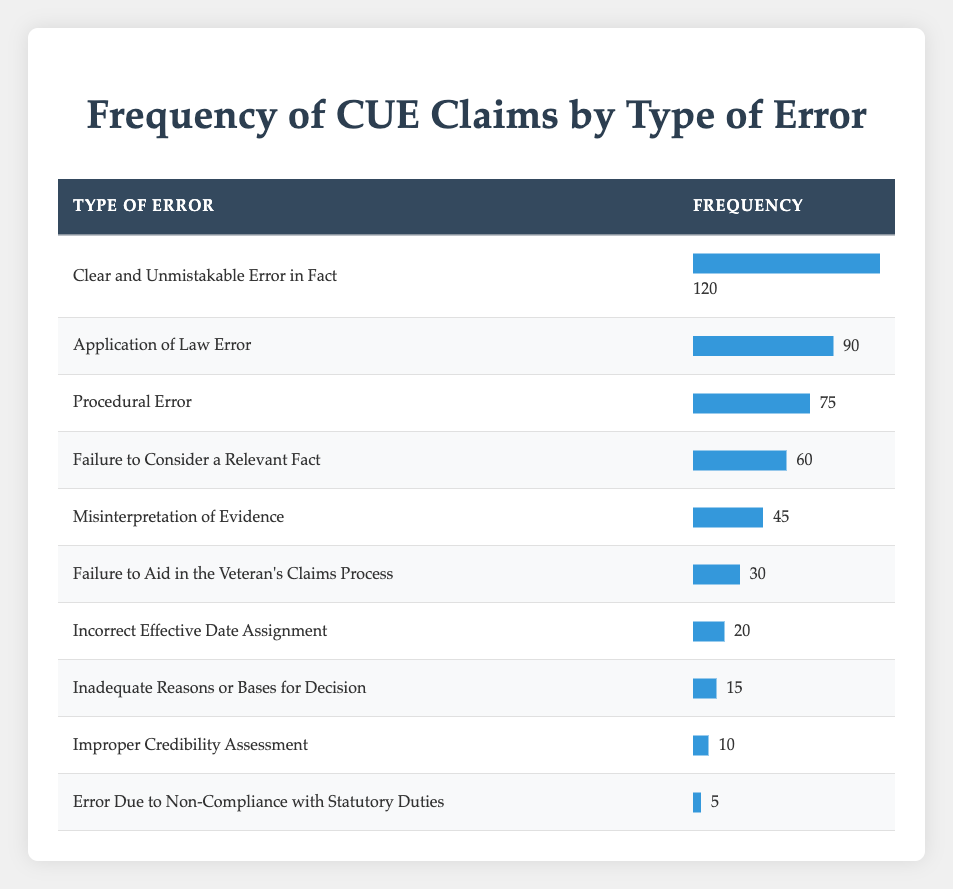What is the frequency of the most common type of error? The table shows that the most common type of error is "Clear and Unmistakable Error in Fact," which has a frequency of 120.
Answer: 120 What is the frequency of "Misinterpretation of Evidence"? By looking at the table, we can see that "Misinterpretation of Evidence" has a frequency of 45.
Answer: 45 Is the frequency of "Procedural Error" greater than that of "Failure to Aid in the Veteran's Claims Process"? The frequency of "Procedural Error" is 75, while "Failure to Aid in the Veteran's Claims Process" has a frequency of 30. Since 75 is greater than 30, the statement is true.
Answer: Yes What is the total frequency of all the errors listed in the table? To find the total frequency, we add up all the frequencies: 120 + 90 + 75 + 60 + 45 + 30 + 20 + 15 + 10 + 5 = 510.
Answer: 510 What percentage of the total frequency do "Incorrect Effective Date Assignment" claims represent? First, we need the total frequency, which is 510. The frequency for "Incorrect Effective Date Assignment" is 20. The percentage is calculated as (20 / 510) * 100, which is approximately 3.92%.
Answer: 3.92% Is there an error type listed that has a frequency under 10? Looking at the table, the lowest frequency is for "Error Due to Non-Compliance with Statutory Duties," which has a frequency of 5. Since this is under 10, the statement is true.
Answer: Yes How many types of errors have a frequency greater than or equal to 60? We can observe the frequencies and count those that are 60 or higher: "Clear and Unmistakable Error in Fact" (120), "Application of Law Error" (90), "Procedural Error" (75), and "Failure to Consider a Relevant Fact" (60) — totaling 4 types of errors.
Answer: 4 What is the difference in frequency between "Failure to Consider a Relevant Fact" and "Misinterpretation of Evidence"? The frequency for "Failure to Consider a Relevant Fact" is 60 and for "Misinterpretation of Evidence" is 45. The difference is 60 - 45 = 15.
Answer: 15 Which error type has the second highest frequency? Upon reviewing the table, "Application of Law Error" has a frequency of 90, making it the second highest after "Clear and Unmistakable Error in Fact" (120).
Answer: Application of Law Error 